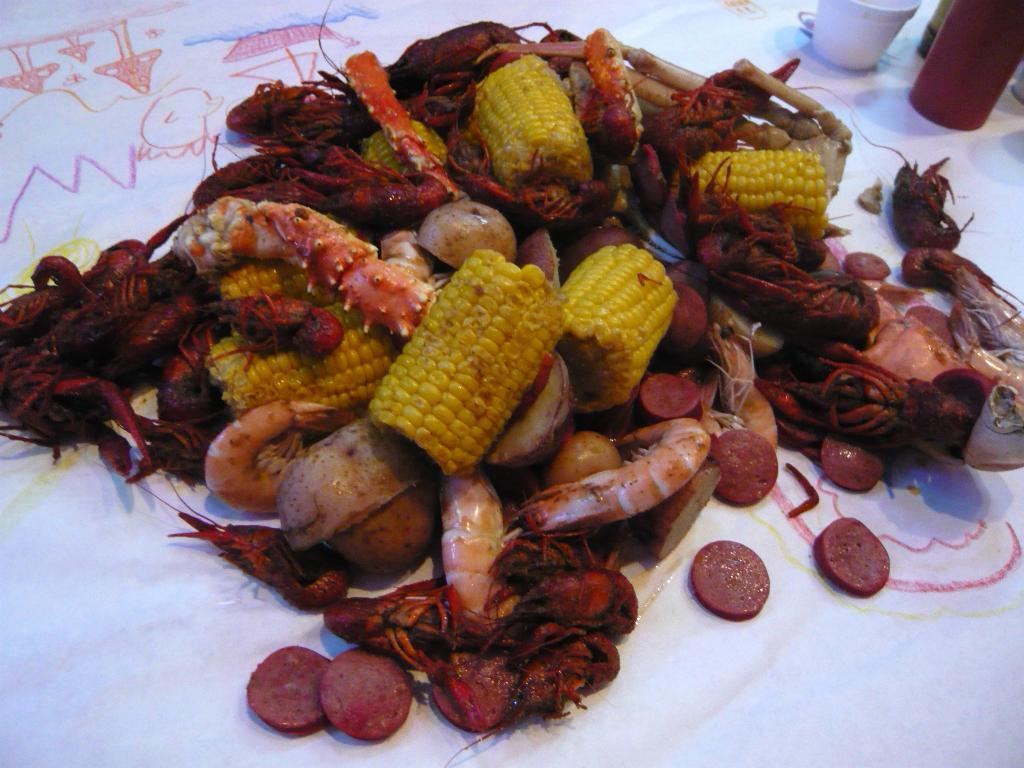What type of food item is present in the image? There is a food item with corns in the image. What are some of the ingredients in the food item? The food item contains prawns and pieces of sausages. Are there any other ingredients in the food item? Yes, there are other items in the food item. What objects are present in the image besides the food item? There is a bowl and a bottle in the image. Where are the food item, bowl, and bottle located? They are on a white surface. What can be seen on the white surface? The white surface has drawings on it. What type of gold jewelry is visible in the image? There is no gold jewelry present in the image. What is the aftermath of the event that took place in the image? There is no event depicted in the image, so it's not possible to determine the aftermath. 